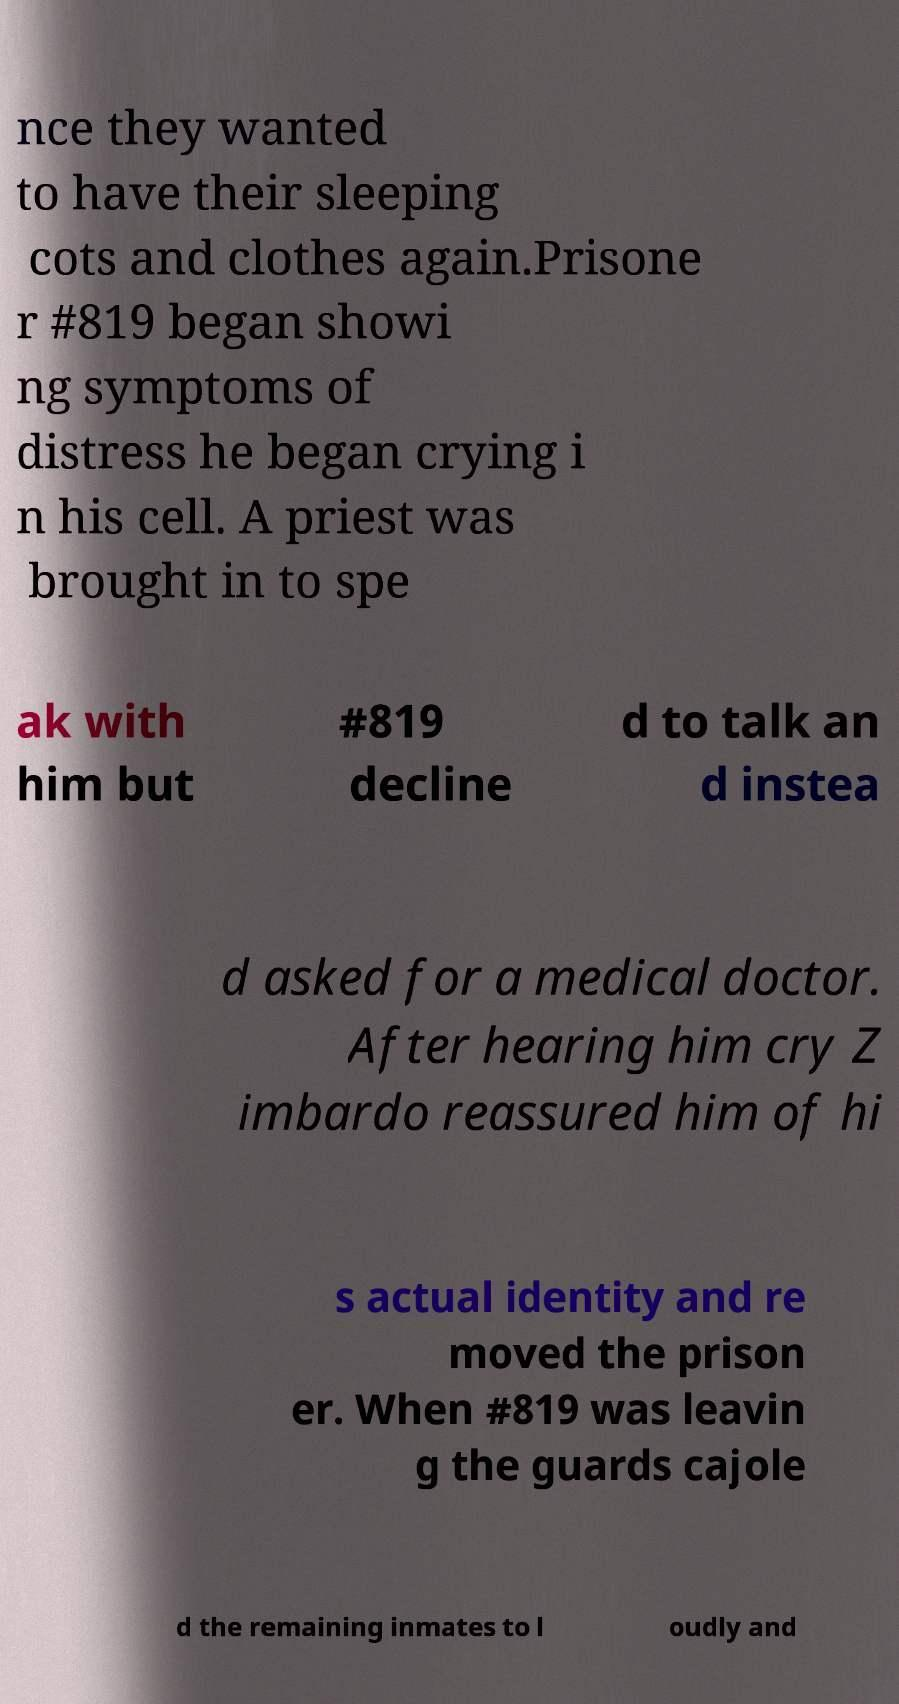Please identify and transcribe the text found in this image. nce they wanted to have their sleeping cots and clothes again.Prisone r #819 began showi ng symptoms of distress he began crying i n his cell. A priest was brought in to spe ak with him but #819 decline d to talk an d instea d asked for a medical doctor. After hearing him cry Z imbardo reassured him of hi s actual identity and re moved the prison er. When #819 was leavin g the guards cajole d the remaining inmates to l oudly and 